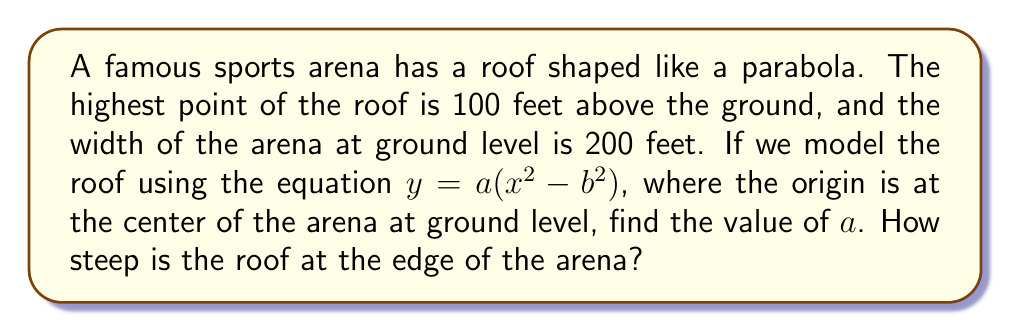Give your solution to this math problem. Let's approach this step-by-step:

1) The parabola equation is given as $y = a(x^2 - b^2)$, where $(0, 100)$ is the vertex.

2) We know that $b = 100$ feet, as this is half the width of the arena.

3) At the vertex $(0, 100)$, we can write:
   $100 = a(0^2 - 100^2)$
   $100 = -10000a$

4) Solving for $a$:
   $a = -\frac{1}{100} = -0.01$

5) So, the equation of the parabola is:
   $y = -0.01(x^2 - 10000)$

6) To find the steepness at the edge, we need to calculate the derivative at $x = 100$:
   $\frac{dy}{dx} = -0.01(2x)$
   At $x = 100$: $\frac{dy}{dx} = -0.01(200) = -2$

7) The slope of -2 means that for every 1 unit horizontally, the roof drops 2 units vertically at the edge.

8) We can convert this to an angle using arctangent:
   $\theta = \arctan(2) \approx 63.4°$
Answer: $a = -0.01$; The roof slope is -2 or approximately 63.4° at the edge. 